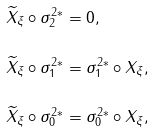Convert formula to latex. <formula><loc_0><loc_0><loc_500><loc_500>\widetilde { X } _ { \xi } \circ \sigma _ { 2 } ^ { 2 * } & = 0 , \\ \widetilde { X } _ { \xi } \circ \sigma _ { 1 } ^ { 2 * } & = \sigma _ { 1 } ^ { 2 * } \circ X _ { \xi } , \\ \widetilde { X } _ { \xi } \circ \sigma _ { 0 } ^ { 2 * } & = \sigma _ { 0 } ^ { 2 * } \circ X _ { \xi } ,</formula> 